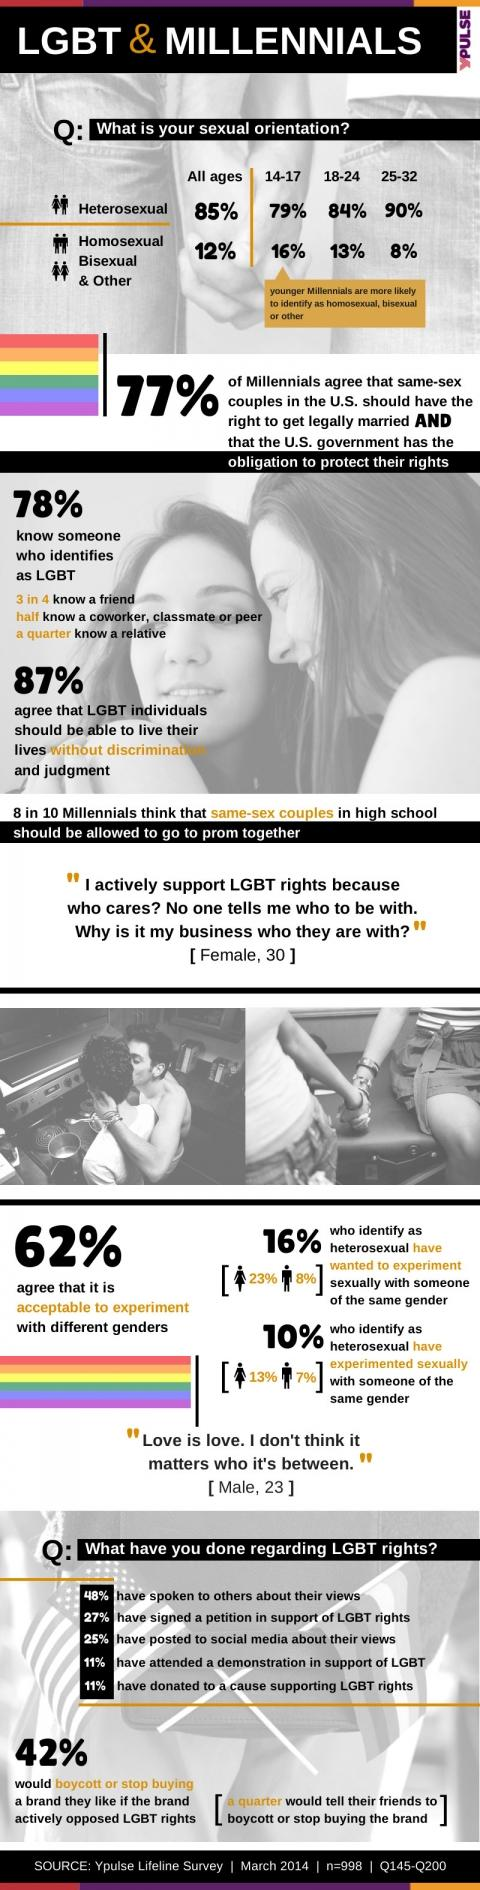Indicate a few pertinent items in this graphic. The age group of 18-24 has the second highest number of LGBT individuals. 